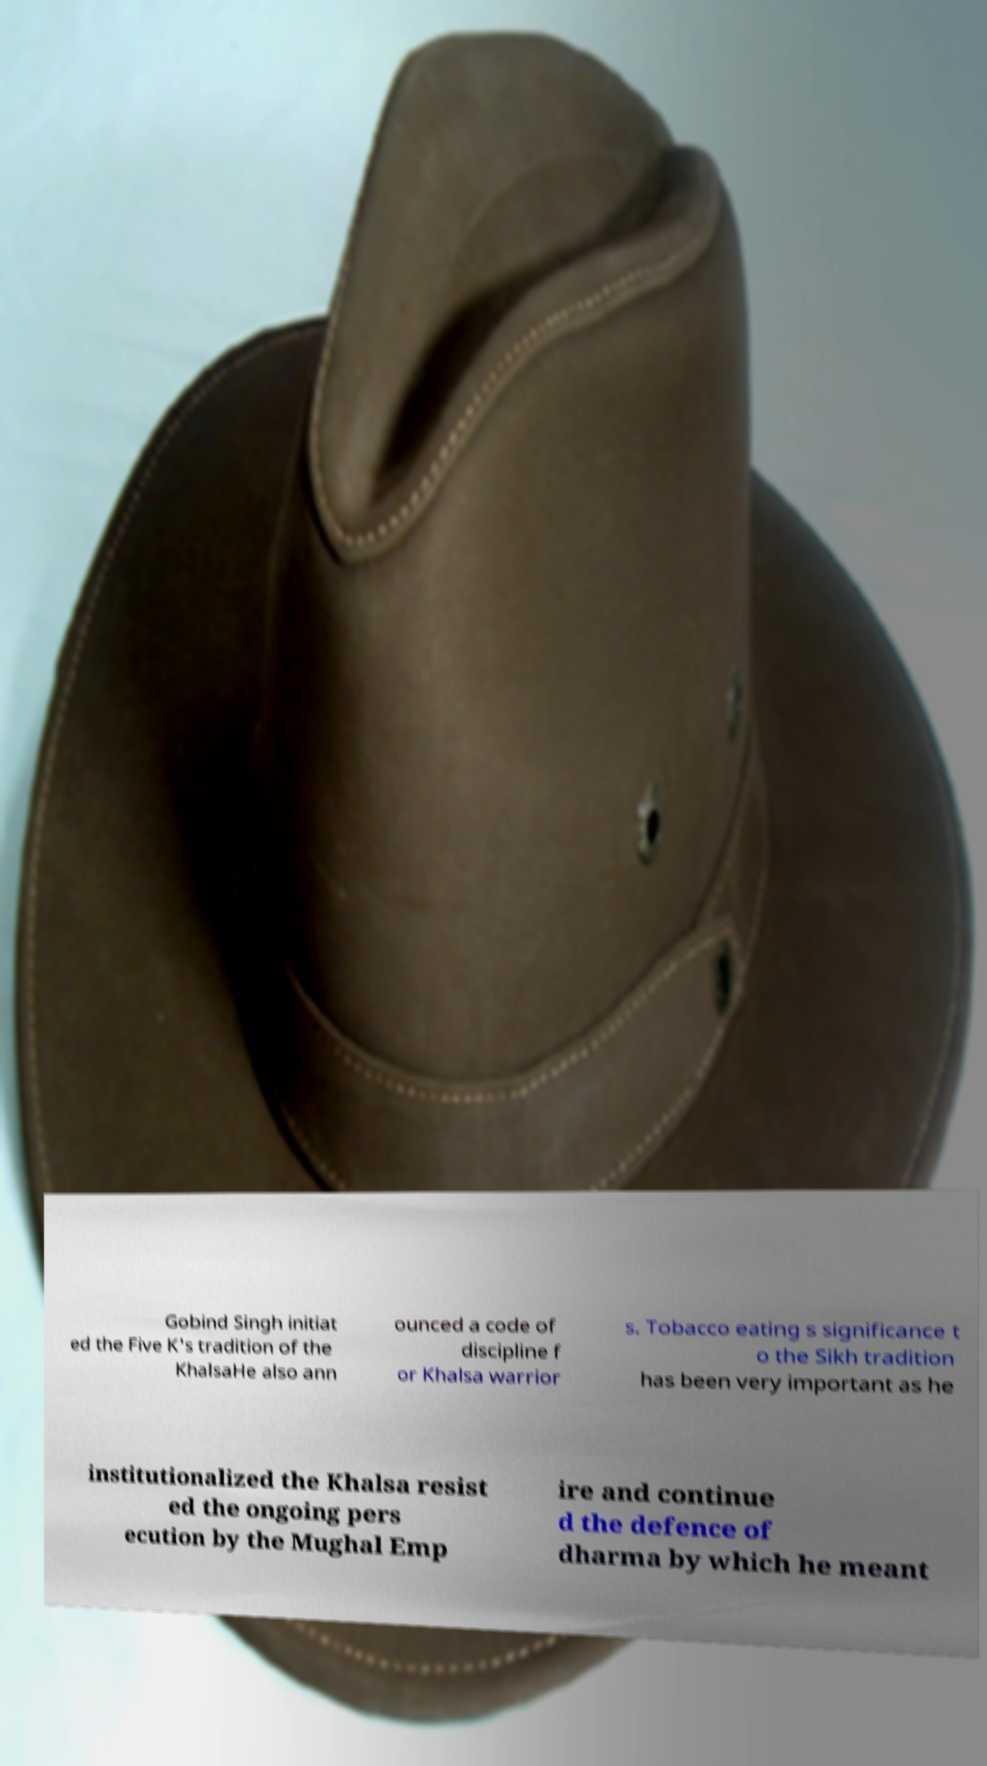Please identify and transcribe the text found in this image. Gobind Singh initiat ed the Five K's tradition of the KhalsaHe also ann ounced a code of discipline f or Khalsa warrior s. Tobacco eating s significance t o the Sikh tradition has been very important as he institutionalized the Khalsa resist ed the ongoing pers ecution by the Mughal Emp ire and continue d the defence of dharma by which he meant 